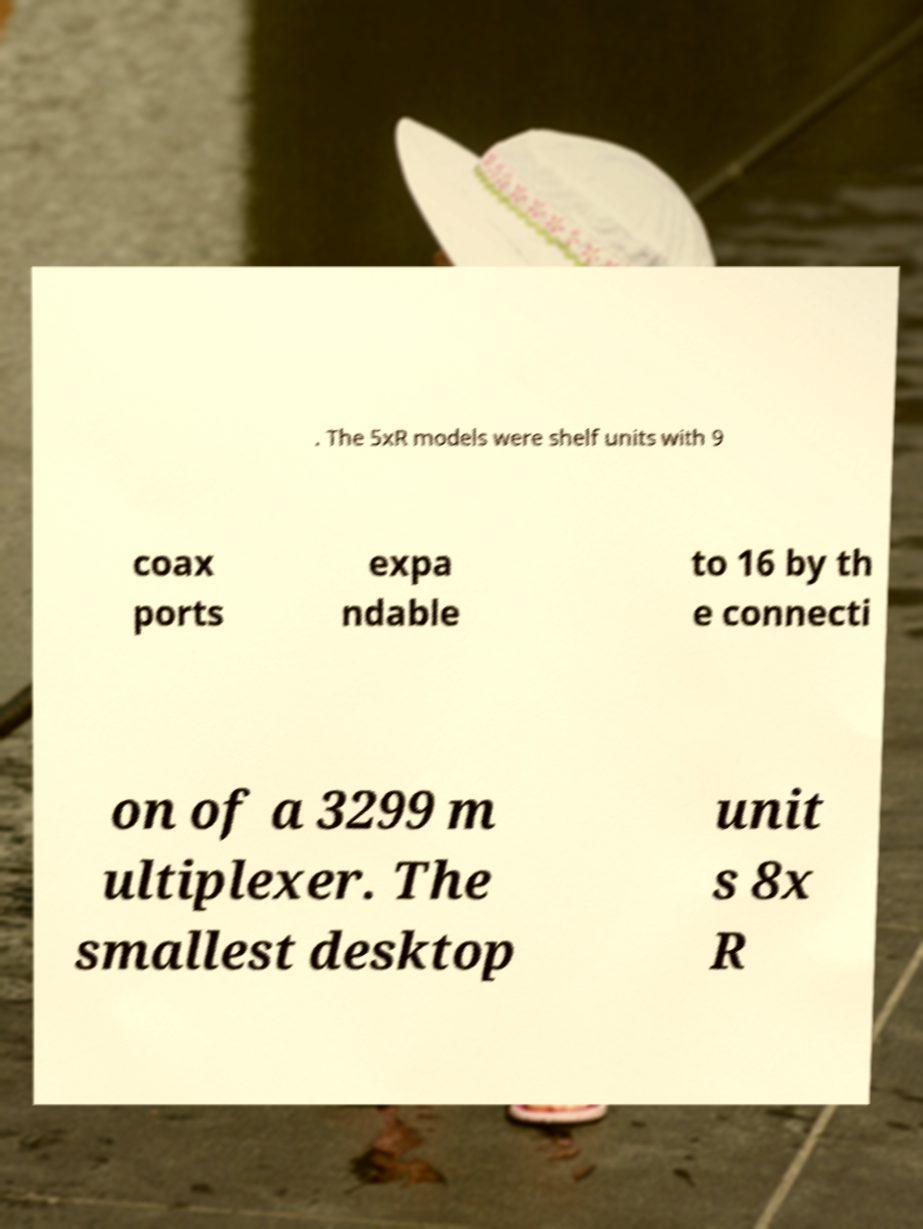What messages or text are displayed in this image? I need them in a readable, typed format. . The 5xR models were shelf units with 9 coax ports expa ndable to 16 by th e connecti on of a 3299 m ultiplexer. The smallest desktop unit s 8x R 